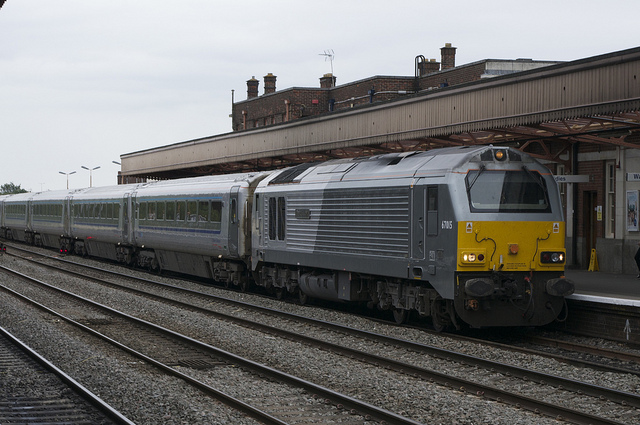Judging from the surroundings, does this appear to be a busy station? While the photo doesn't show any passengers, the infrastructure, such as the extensive platform and multiple train tracks, suggests that this station is designed to handle a considerable amount of traffic. The overall tidiness and maintenance of the station also point to it being an active and well-used transit point. 